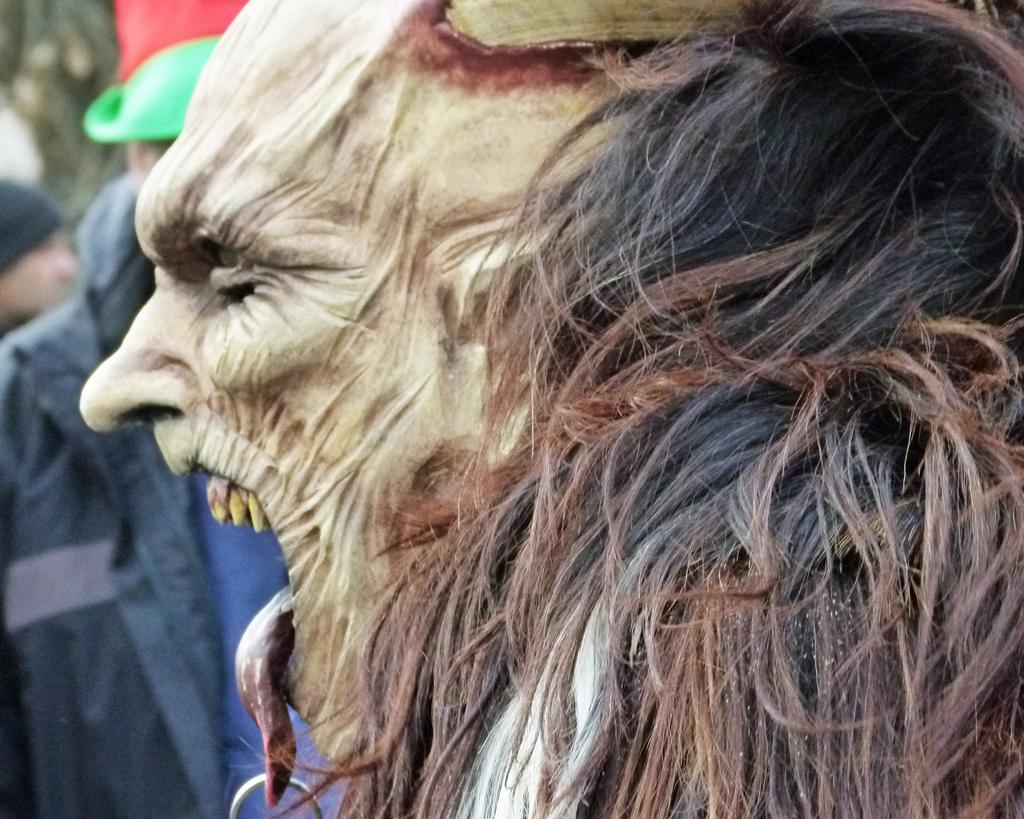Describe this image in one or two sentences. In this image I see a person who is wearing a mask and I see a thing on the tongue. In the background I see another person. 